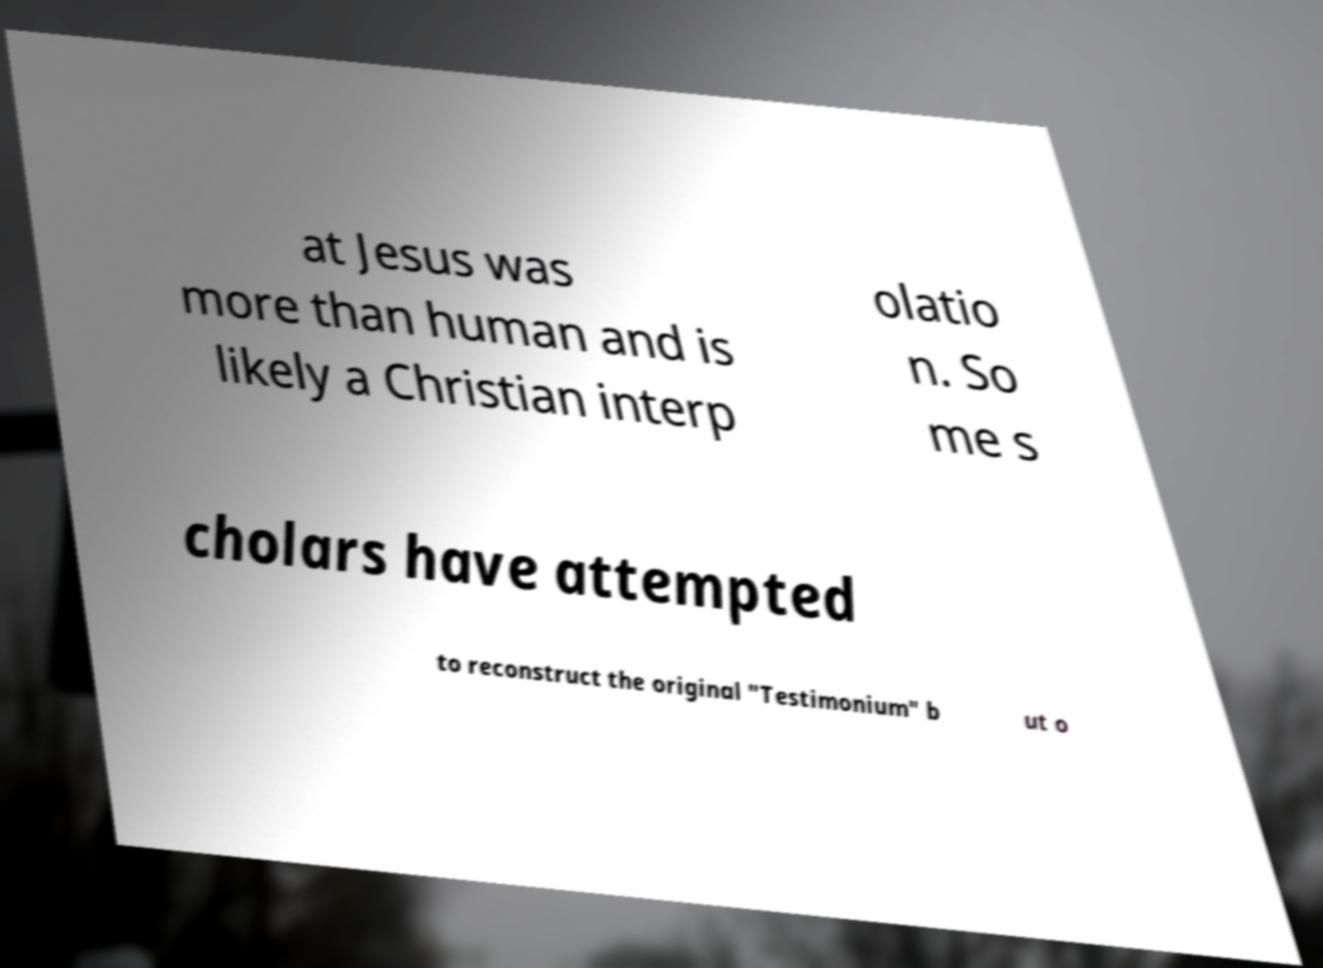There's text embedded in this image that I need extracted. Can you transcribe it verbatim? at Jesus was more than human and is likely a Christian interp olatio n. So me s cholars have attempted to reconstruct the original "Testimonium" b ut o 